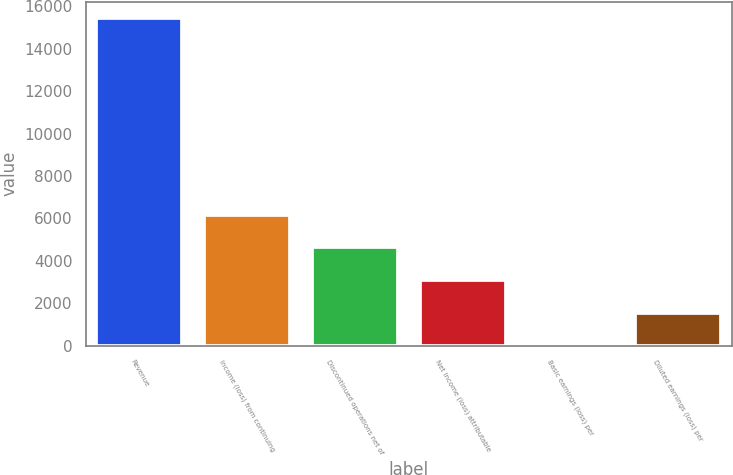Convert chart. <chart><loc_0><loc_0><loc_500><loc_500><bar_chart><fcel>Revenue<fcel>Income (loss) from continuing<fcel>Discontinued operations net of<fcel>Net income (loss) attributable<fcel>Basic earnings (loss) per<fcel>Diluted earnings (loss) per<nl><fcel>15443<fcel>6177.21<fcel>4632.91<fcel>3088.61<fcel>0.01<fcel>1544.31<nl></chart> 